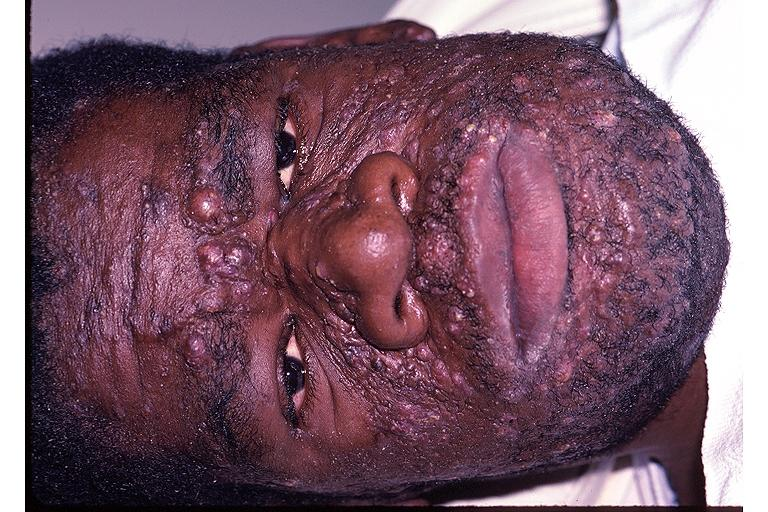does malformed base show neurofibromatosis?
Answer the question using a single word or phrase. No 